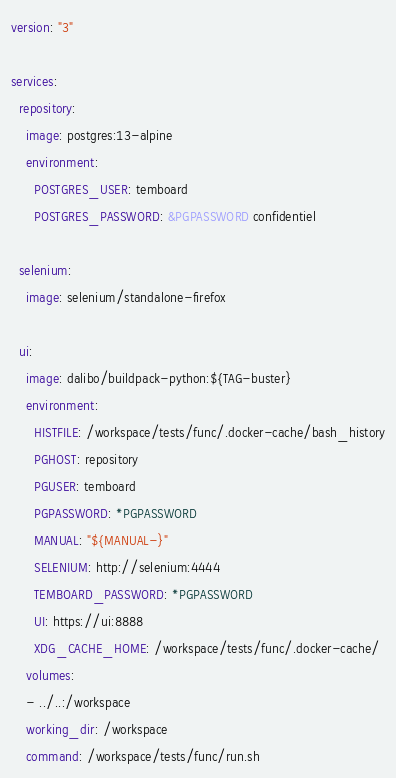Convert code to text. <code><loc_0><loc_0><loc_500><loc_500><_YAML_>version: "3"

services:
  repository:
    image: postgres:13-alpine
    environment:
      POSTGRES_USER: temboard
      POSTGRES_PASSWORD: &PGPASSWORD confidentiel

  selenium:
    image: selenium/standalone-firefox

  ui:
    image: dalibo/buildpack-python:${TAG-buster}
    environment:
      HISTFILE: /workspace/tests/func/.docker-cache/bash_history
      PGHOST: repository
      PGUSER: temboard
      PGPASSWORD: *PGPASSWORD
      MANUAL: "${MANUAL-}"
      SELENIUM: http://selenium:4444
      TEMBOARD_PASSWORD: *PGPASSWORD
      UI: https://ui:8888
      XDG_CACHE_HOME: /workspace/tests/func/.docker-cache/
    volumes:
    - ../..:/workspace
    working_dir: /workspace
    command: /workspace/tests/func/run.sh
</code> 